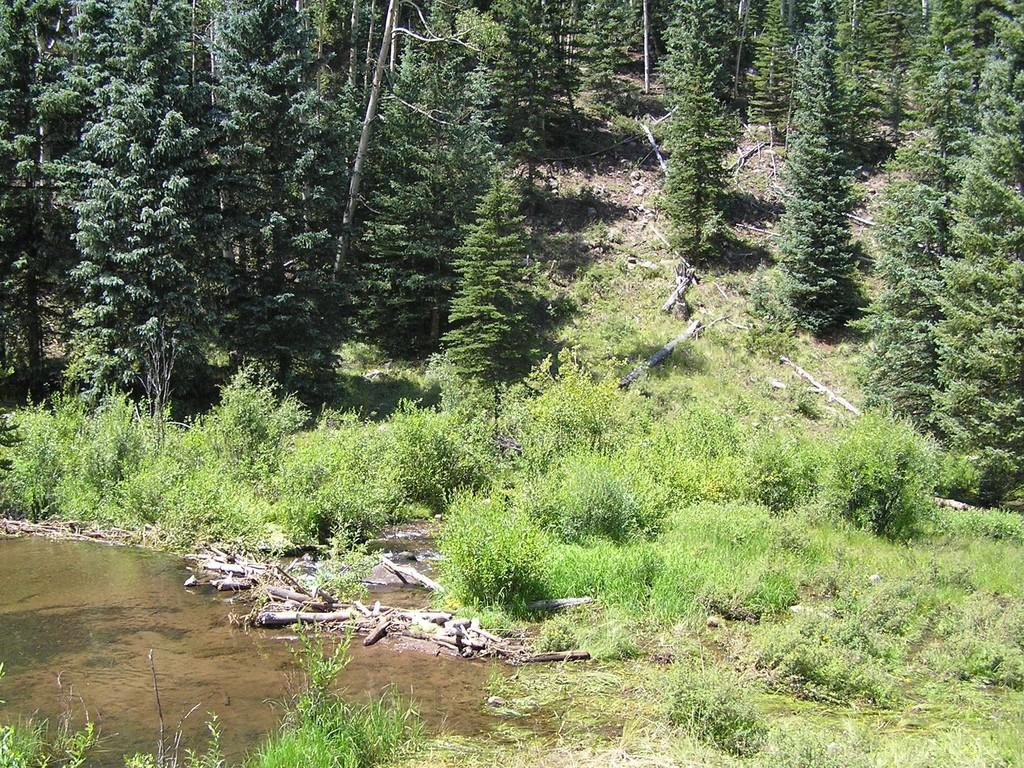What is located on the left side of the image? There is water on the left side of the image. What type of natural elements can be seen in the image? There are plants, wooden barks, and trees in the image. Can you describe the vegetation in the image? The vegetation includes plants and trees. How many buckets of water are being carried by the bee in the image? There is no bee present in the image, and therefore no buckets of water are being carried. What is the bee's wish in the image? There is no bee present in the image, so it is not possible to determine its wish. 